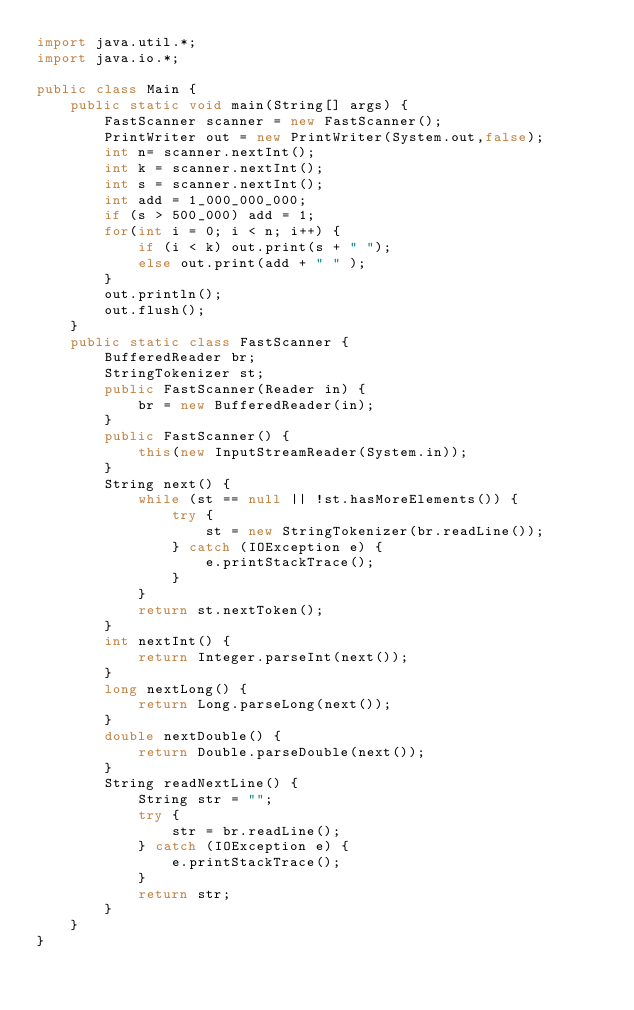Convert code to text. <code><loc_0><loc_0><loc_500><loc_500><_Java_>import java.util.*;
import java.io.*;

public class Main {
    public static void main(String[] args) {
        FastScanner scanner = new FastScanner();
        PrintWriter out = new PrintWriter(System.out,false);
        int n= scanner.nextInt();
        int k = scanner.nextInt();
        int s = scanner.nextInt();
        int add = 1_000_000_000;
        if (s > 500_000) add = 1;
        for(int i = 0; i < n; i++) {
            if (i < k) out.print(s + " ");
            else out.print(add + " " );
        }
        out.println();
        out.flush();
    }
    public static class FastScanner {
        BufferedReader br;
        StringTokenizer st;
        public FastScanner(Reader in) {
            br = new BufferedReader(in);
        }
        public FastScanner() {
            this(new InputStreamReader(System.in));
        }
        String next() {
            while (st == null || !st.hasMoreElements()) {
                try {
                    st = new StringTokenizer(br.readLine());
                } catch (IOException e) {
                    e.printStackTrace();
                }
            }
            return st.nextToken();
        }
        int nextInt() {
            return Integer.parseInt(next());
        }
        long nextLong() {
            return Long.parseLong(next());
        }
        double nextDouble() {
            return Double.parseDouble(next());
        }
        String readNextLine() {
            String str = "";
            try {
                str = br.readLine();
            } catch (IOException e) {
                e.printStackTrace();
            }
            return str;
        }
    }
}
</code> 